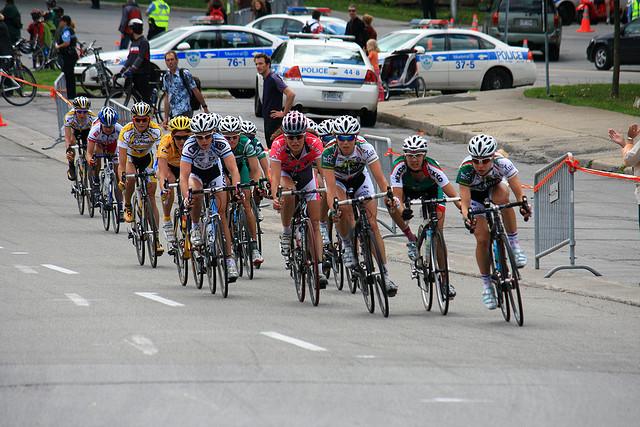What country is this located?
Keep it brief. France. What number of people are on bikes?
Give a very brief answer. 12. What is nearly everyone wearing on their head?
Give a very brief answer. Helmet. What colors are the biker's helmets?
Give a very brief answer. Black, white, yellow, blue. How many police cars are in this picture?
Give a very brief answer. 4. 